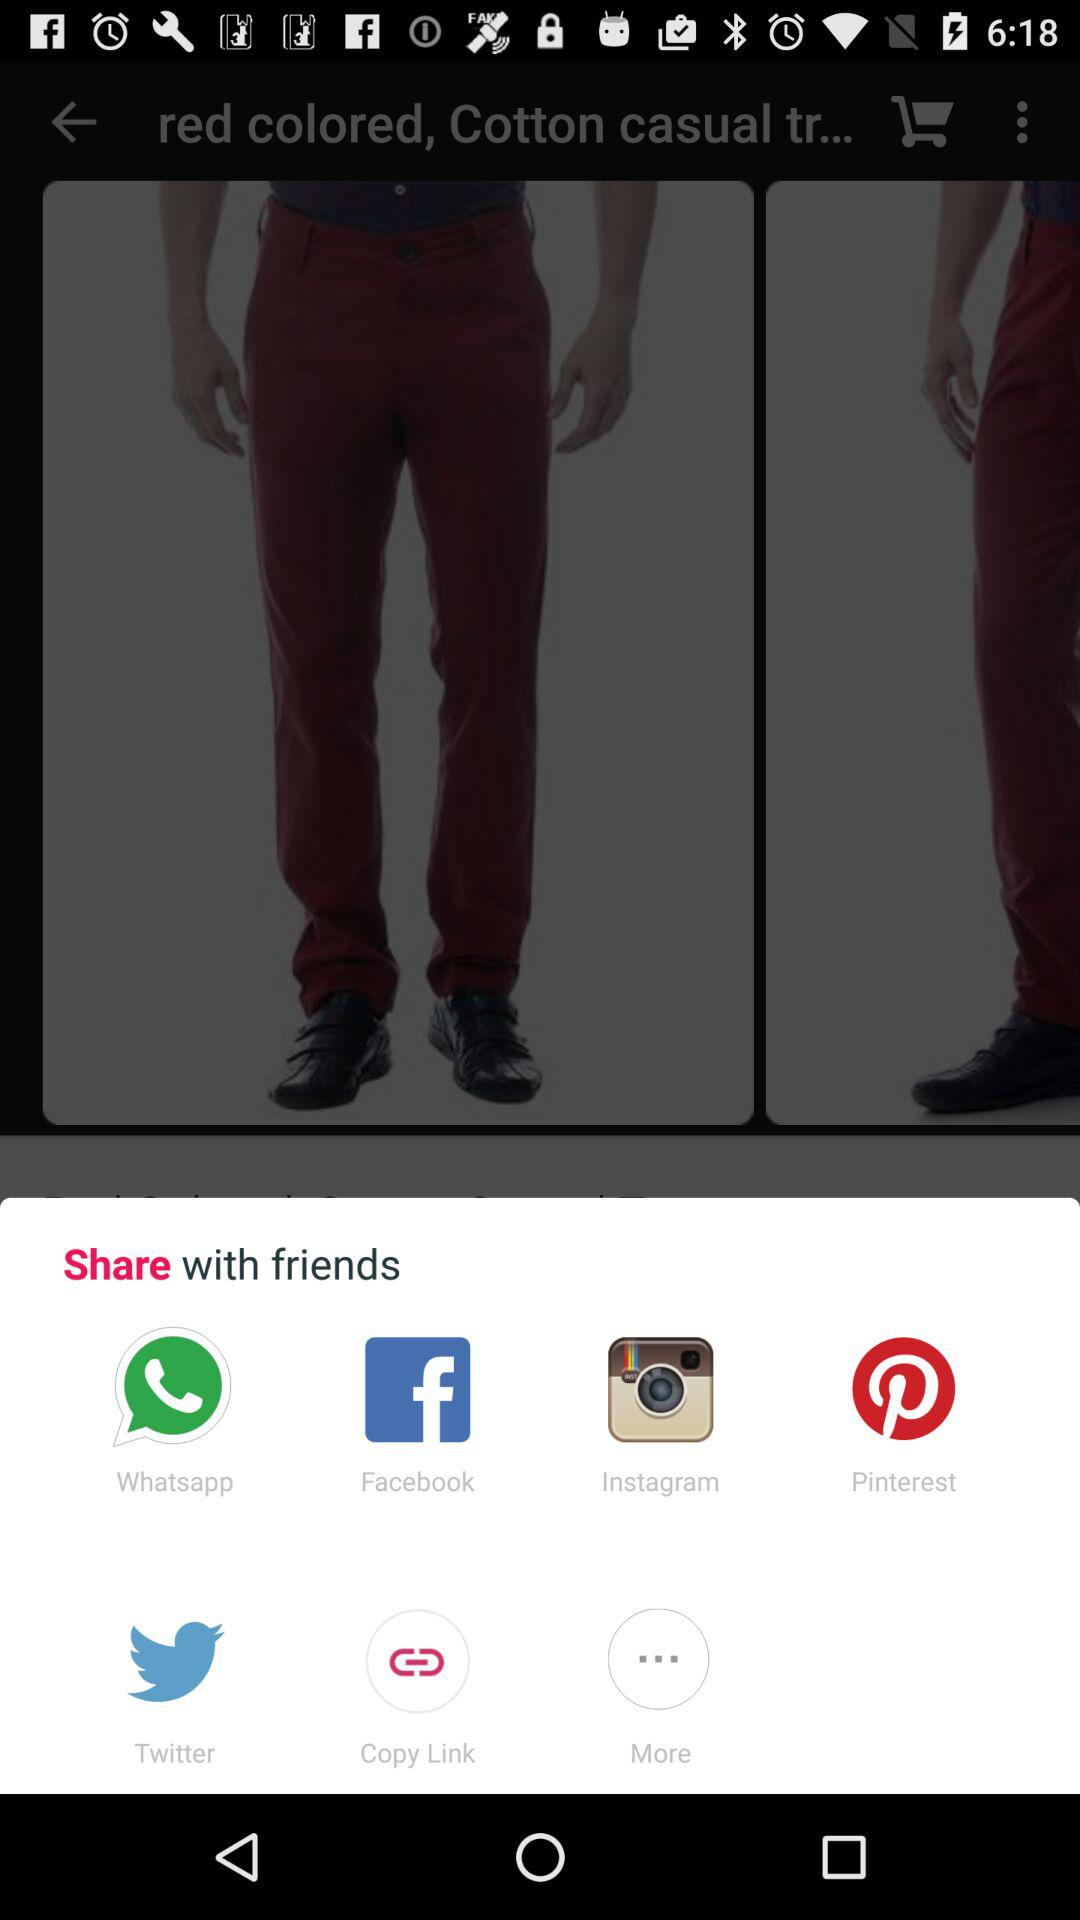What applications can I use to share? You can use "Whatsapp", "Facebook", "Instagram", "Pinterest" and "Twitter" to share. 